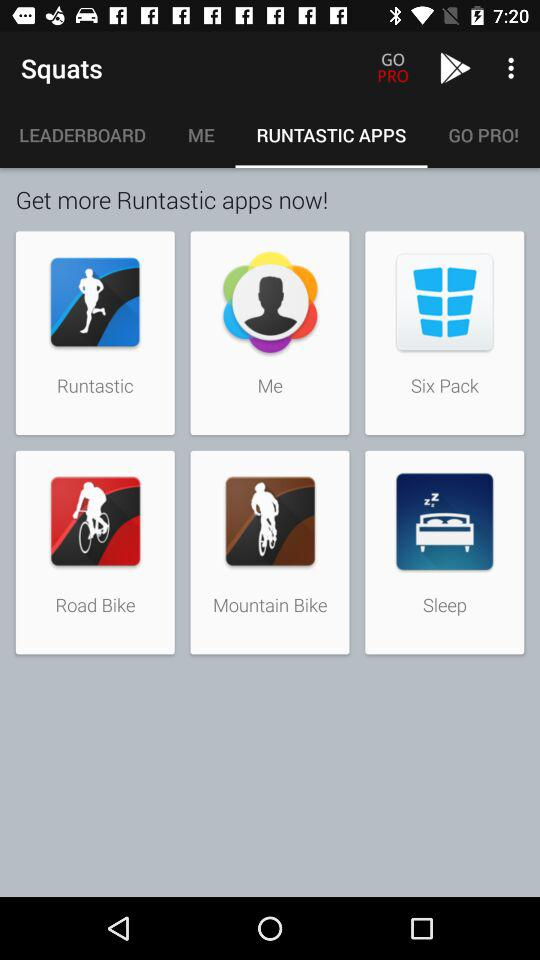How many items are in "ME"?
When the provided information is insufficient, respond with <no answer>. <no answer> 